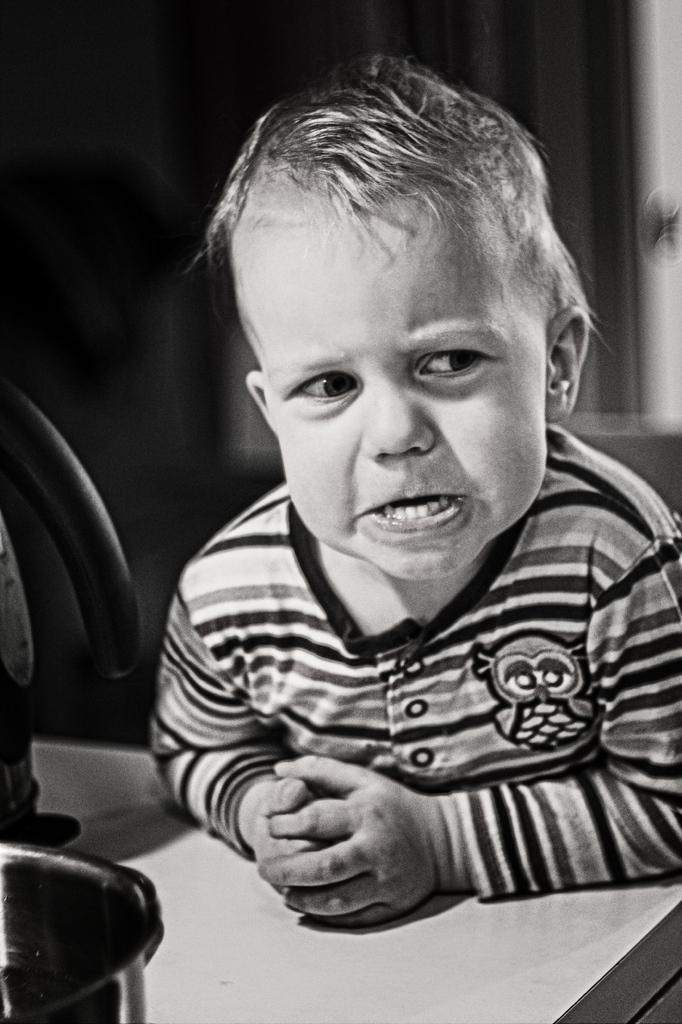How would you summarize this image in a sentence or two? This is a black and white image. We can see a kid and some objects on the left. We can also see the blurred background. 